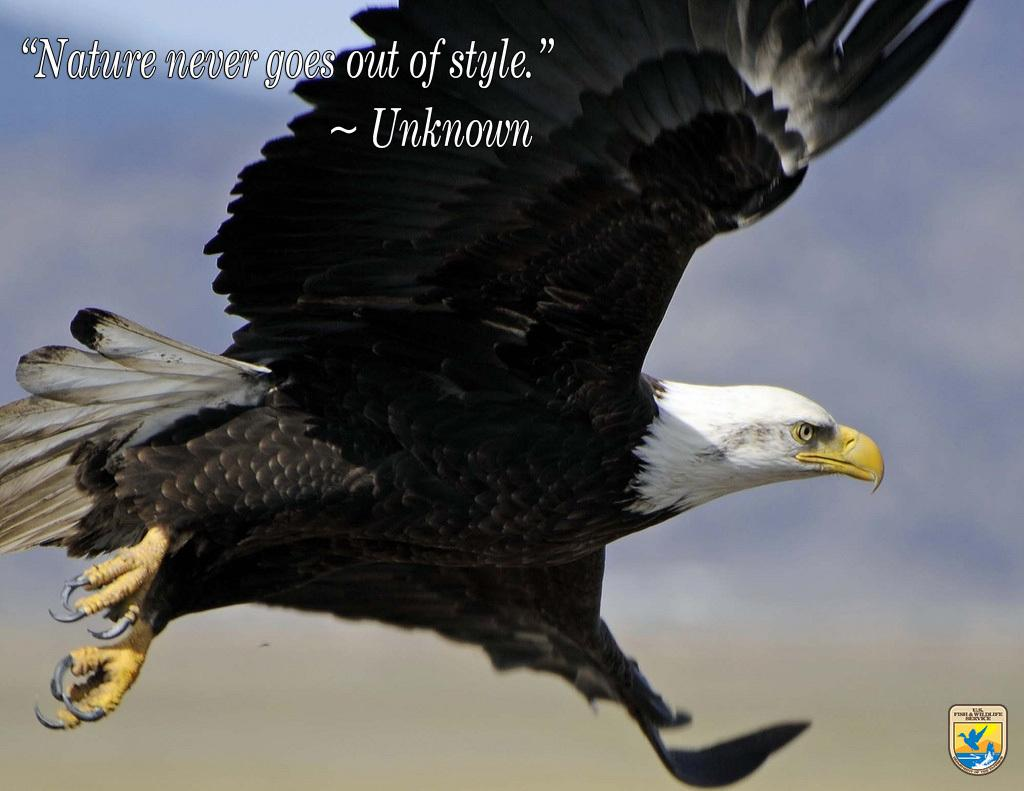What type of animal can be seen in the image? There is a bird in the air in the image. What is written at the top of the image? There is some text written at the top of the image. Where is the jail located in the image? There is no jail present in the image. What type of cream is being used by the bird in the image? There is no cream present in the image, and the bird is not using any cream. Can you see a needle being used by the bird in the image? There is no needle present in the image, and the bird is not using any needle. 